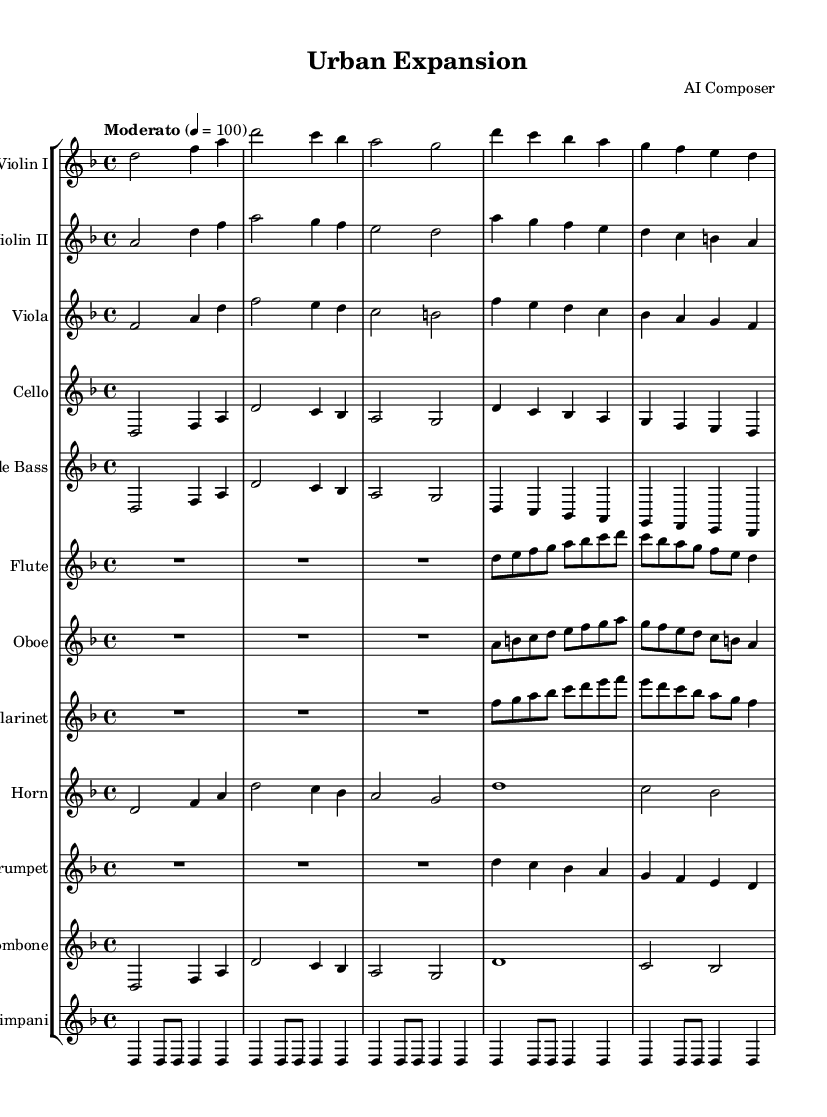What is the key signature of this music? The key signature is D minor, which includes one flat (B flat). This can be found by checking the key signature section at the beginning of the score, which indicates that it is in D minor.
Answer: D minor What is the time signature of this music? The time signature is 4/4, which means there are four beats in each measure and a quarter note gets one beat. This can be observed in the time signature marking found at the beginning of the music.
Answer: 4/4 What is the tempo of the piece? The tempo marking indicates "Moderato" at 100 beats per minute. This shows that the piece should be played at a moderate speed. The tempo is indicated right after the time signature and key signature.
Answer: Moderato 4 = 100 How many measures are in the introduction section? The introduction section has 6 measures. This can be determined by counting the measures from the start of the piece until the transition into Theme A. Each group of notes separated by vertical lines represents a measure.
Answer: 6 Which instrument has the highest pitch in the Theme A? The flute has the highest pitch in Theme A. I can deduce this by comparing the written notes in the scores for the flute and other instruments within Theme A, noting the note values used. The flute's melody rises to the highest pitch among them.
Answer: Flute How does the texture change from the introduction to Theme A? The texture becomes denser in Theme A. In the introduction, each instrument plays a simpler line, but when reaching Theme A, we can see that multiple instruments play simultaneously, creating a fuller sound. This indicates a more complex structure in terms of instrumentation and harmonic layering.
Answer: Denser What instruments are playing during the introduction? The instruments playing during the introduction are Violin I, Violin II, Viola, Cello, Double Bass, Flute, Oboe, Clarinet, Horn, Trumpet, Trombone, and Timpani. This can be confirmed by looking at the staves in the score, where each instrument's part is labeled and shows when they commence playing.
Answer: All listed instruments 